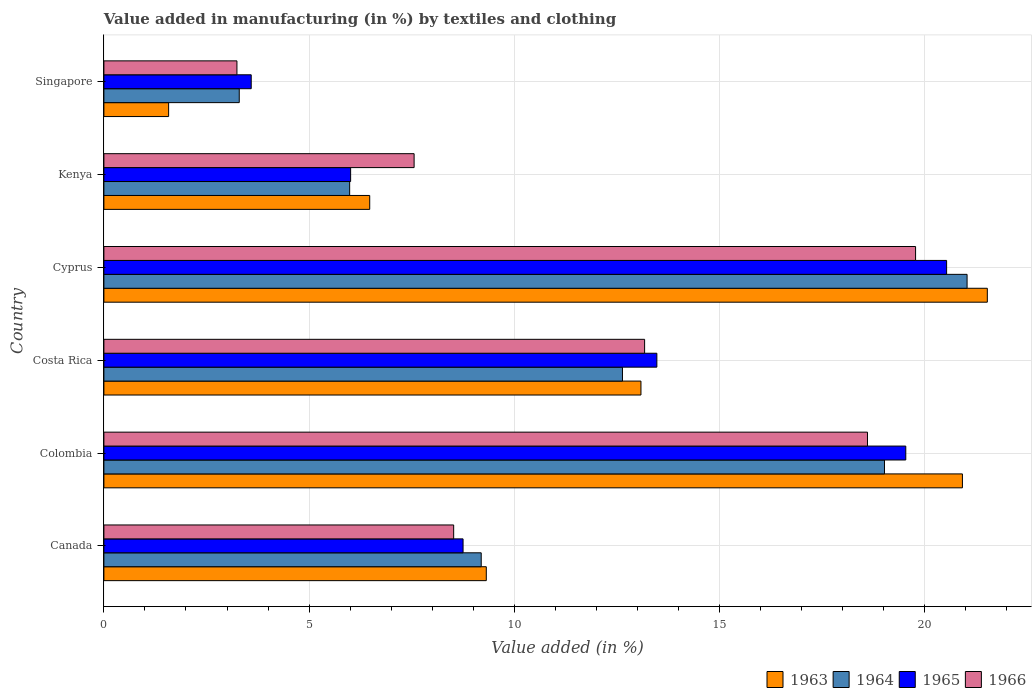How many groups of bars are there?
Provide a short and direct response. 6. How many bars are there on the 1st tick from the top?
Make the answer very short. 4. How many bars are there on the 3rd tick from the bottom?
Offer a terse response. 4. What is the label of the 4th group of bars from the top?
Make the answer very short. Costa Rica. In how many cases, is the number of bars for a given country not equal to the number of legend labels?
Give a very brief answer. 0. What is the percentage of value added in manufacturing by textiles and clothing in 1963 in Costa Rica?
Your answer should be compact. 13.08. Across all countries, what is the maximum percentage of value added in manufacturing by textiles and clothing in 1966?
Offer a very short reply. 19.78. Across all countries, what is the minimum percentage of value added in manufacturing by textiles and clothing in 1965?
Your answer should be very brief. 3.59. In which country was the percentage of value added in manufacturing by textiles and clothing in 1966 maximum?
Offer a very short reply. Cyprus. In which country was the percentage of value added in manufacturing by textiles and clothing in 1963 minimum?
Your answer should be very brief. Singapore. What is the total percentage of value added in manufacturing by textiles and clothing in 1966 in the graph?
Ensure brevity in your answer.  70.87. What is the difference between the percentage of value added in manufacturing by textiles and clothing in 1965 in Colombia and that in Singapore?
Give a very brief answer. 15.95. What is the difference between the percentage of value added in manufacturing by textiles and clothing in 1966 in Colombia and the percentage of value added in manufacturing by textiles and clothing in 1963 in Singapore?
Make the answer very short. 17.03. What is the average percentage of value added in manufacturing by textiles and clothing in 1965 per country?
Give a very brief answer. 11.98. What is the difference between the percentage of value added in manufacturing by textiles and clothing in 1965 and percentage of value added in manufacturing by textiles and clothing in 1963 in Singapore?
Offer a terse response. 2.01. In how many countries, is the percentage of value added in manufacturing by textiles and clothing in 1963 greater than 8 %?
Offer a very short reply. 4. What is the ratio of the percentage of value added in manufacturing by textiles and clothing in 1965 in Colombia to that in Cyprus?
Give a very brief answer. 0.95. Is the difference between the percentage of value added in manufacturing by textiles and clothing in 1965 in Costa Rica and Cyprus greater than the difference between the percentage of value added in manufacturing by textiles and clothing in 1963 in Costa Rica and Cyprus?
Provide a succinct answer. Yes. What is the difference between the highest and the second highest percentage of value added in manufacturing by textiles and clothing in 1966?
Offer a very short reply. 1.17. What is the difference between the highest and the lowest percentage of value added in manufacturing by textiles and clothing in 1965?
Offer a terse response. 16.94. Is the sum of the percentage of value added in manufacturing by textiles and clothing in 1965 in Cyprus and Singapore greater than the maximum percentage of value added in manufacturing by textiles and clothing in 1966 across all countries?
Make the answer very short. Yes. Is it the case that in every country, the sum of the percentage of value added in manufacturing by textiles and clothing in 1964 and percentage of value added in manufacturing by textiles and clothing in 1965 is greater than the sum of percentage of value added in manufacturing by textiles and clothing in 1966 and percentage of value added in manufacturing by textiles and clothing in 1963?
Your response must be concise. No. What does the 2nd bar from the bottom in Singapore represents?
Provide a succinct answer. 1964. How many countries are there in the graph?
Your response must be concise. 6. What is the difference between two consecutive major ticks on the X-axis?
Provide a succinct answer. 5. Does the graph contain any zero values?
Provide a short and direct response. No. Does the graph contain grids?
Provide a short and direct response. Yes. Where does the legend appear in the graph?
Provide a succinct answer. Bottom right. How many legend labels are there?
Offer a very short reply. 4. How are the legend labels stacked?
Your answer should be compact. Horizontal. What is the title of the graph?
Make the answer very short. Value added in manufacturing (in %) by textiles and clothing. Does "1983" appear as one of the legend labels in the graph?
Give a very brief answer. No. What is the label or title of the X-axis?
Give a very brief answer. Value added (in %). What is the Value added (in %) of 1963 in Canada?
Provide a succinct answer. 9.32. What is the Value added (in %) of 1964 in Canada?
Your response must be concise. 9.19. What is the Value added (in %) in 1965 in Canada?
Make the answer very short. 8.75. What is the Value added (in %) of 1966 in Canada?
Your answer should be compact. 8.52. What is the Value added (in %) of 1963 in Colombia?
Your answer should be very brief. 20.92. What is the Value added (in %) in 1964 in Colombia?
Provide a short and direct response. 19.02. What is the Value added (in %) of 1965 in Colombia?
Provide a short and direct response. 19.54. What is the Value added (in %) of 1966 in Colombia?
Provide a succinct answer. 18.6. What is the Value added (in %) in 1963 in Costa Rica?
Your response must be concise. 13.08. What is the Value added (in %) in 1964 in Costa Rica?
Your answer should be very brief. 12.63. What is the Value added (in %) of 1965 in Costa Rica?
Your response must be concise. 13.47. What is the Value added (in %) in 1966 in Costa Rica?
Your response must be concise. 13.17. What is the Value added (in %) of 1963 in Cyprus?
Ensure brevity in your answer.  21.52. What is the Value added (in %) in 1964 in Cyprus?
Provide a succinct answer. 21.03. What is the Value added (in %) of 1965 in Cyprus?
Provide a short and direct response. 20.53. What is the Value added (in %) of 1966 in Cyprus?
Your answer should be very brief. 19.78. What is the Value added (in %) in 1963 in Kenya?
Your answer should be compact. 6.48. What is the Value added (in %) in 1964 in Kenya?
Keep it short and to the point. 5.99. What is the Value added (in %) in 1965 in Kenya?
Offer a very short reply. 6.01. What is the Value added (in %) of 1966 in Kenya?
Your answer should be compact. 7.56. What is the Value added (in %) in 1963 in Singapore?
Keep it short and to the point. 1.58. What is the Value added (in %) in 1964 in Singapore?
Offer a terse response. 3.3. What is the Value added (in %) in 1965 in Singapore?
Your answer should be very brief. 3.59. What is the Value added (in %) in 1966 in Singapore?
Your answer should be very brief. 3.24. Across all countries, what is the maximum Value added (in %) in 1963?
Offer a very short reply. 21.52. Across all countries, what is the maximum Value added (in %) in 1964?
Keep it short and to the point. 21.03. Across all countries, what is the maximum Value added (in %) in 1965?
Ensure brevity in your answer.  20.53. Across all countries, what is the maximum Value added (in %) of 1966?
Your answer should be compact. 19.78. Across all countries, what is the minimum Value added (in %) in 1963?
Keep it short and to the point. 1.58. Across all countries, what is the minimum Value added (in %) in 1964?
Give a very brief answer. 3.3. Across all countries, what is the minimum Value added (in %) of 1965?
Your response must be concise. 3.59. Across all countries, what is the minimum Value added (in %) of 1966?
Keep it short and to the point. 3.24. What is the total Value added (in %) in 1963 in the graph?
Offer a very short reply. 72.9. What is the total Value added (in %) in 1964 in the graph?
Your response must be concise. 71.16. What is the total Value added (in %) of 1965 in the graph?
Your response must be concise. 71.89. What is the total Value added (in %) of 1966 in the graph?
Offer a terse response. 70.87. What is the difference between the Value added (in %) in 1963 in Canada and that in Colombia?
Offer a very short reply. -11.6. What is the difference between the Value added (in %) in 1964 in Canada and that in Colombia?
Make the answer very short. -9.82. What is the difference between the Value added (in %) in 1965 in Canada and that in Colombia?
Your answer should be very brief. -10.79. What is the difference between the Value added (in %) in 1966 in Canada and that in Colombia?
Make the answer very short. -10.08. What is the difference between the Value added (in %) in 1963 in Canada and that in Costa Rica?
Your response must be concise. -3.77. What is the difference between the Value added (in %) in 1964 in Canada and that in Costa Rica?
Offer a terse response. -3.44. What is the difference between the Value added (in %) in 1965 in Canada and that in Costa Rica?
Offer a very short reply. -4.72. What is the difference between the Value added (in %) in 1966 in Canada and that in Costa Rica?
Provide a short and direct response. -4.65. What is the difference between the Value added (in %) in 1963 in Canada and that in Cyprus?
Your answer should be compact. -12.21. What is the difference between the Value added (in %) of 1964 in Canada and that in Cyprus?
Provide a short and direct response. -11.84. What is the difference between the Value added (in %) of 1965 in Canada and that in Cyprus?
Your response must be concise. -11.78. What is the difference between the Value added (in %) in 1966 in Canada and that in Cyprus?
Give a very brief answer. -11.25. What is the difference between the Value added (in %) in 1963 in Canada and that in Kenya?
Your answer should be compact. 2.84. What is the difference between the Value added (in %) in 1964 in Canada and that in Kenya?
Give a very brief answer. 3.21. What is the difference between the Value added (in %) of 1965 in Canada and that in Kenya?
Ensure brevity in your answer.  2.74. What is the difference between the Value added (in %) of 1966 in Canada and that in Kenya?
Ensure brevity in your answer.  0.96. What is the difference between the Value added (in %) of 1963 in Canada and that in Singapore?
Offer a terse response. 7.74. What is the difference between the Value added (in %) of 1964 in Canada and that in Singapore?
Offer a terse response. 5.9. What is the difference between the Value added (in %) in 1965 in Canada and that in Singapore?
Offer a terse response. 5.16. What is the difference between the Value added (in %) of 1966 in Canada and that in Singapore?
Offer a very short reply. 5.28. What is the difference between the Value added (in %) in 1963 in Colombia and that in Costa Rica?
Your answer should be very brief. 7.83. What is the difference between the Value added (in %) in 1964 in Colombia and that in Costa Rica?
Keep it short and to the point. 6.38. What is the difference between the Value added (in %) of 1965 in Colombia and that in Costa Rica?
Your answer should be compact. 6.06. What is the difference between the Value added (in %) in 1966 in Colombia and that in Costa Rica?
Make the answer very short. 5.43. What is the difference between the Value added (in %) in 1963 in Colombia and that in Cyprus?
Offer a terse response. -0.61. What is the difference between the Value added (in %) in 1964 in Colombia and that in Cyprus?
Offer a very short reply. -2.01. What is the difference between the Value added (in %) in 1965 in Colombia and that in Cyprus?
Make the answer very short. -0.99. What is the difference between the Value added (in %) of 1966 in Colombia and that in Cyprus?
Provide a succinct answer. -1.17. What is the difference between the Value added (in %) in 1963 in Colombia and that in Kenya?
Offer a very short reply. 14.44. What is the difference between the Value added (in %) in 1964 in Colombia and that in Kenya?
Your answer should be compact. 13.03. What is the difference between the Value added (in %) of 1965 in Colombia and that in Kenya?
Your response must be concise. 13.53. What is the difference between the Value added (in %) in 1966 in Colombia and that in Kenya?
Your answer should be very brief. 11.05. What is the difference between the Value added (in %) in 1963 in Colombia and that in Singapore?
Provide a succinct answer. 19.34. What is the difference between the Value added (in %) of 1964 in Colombia and that in Singapore?
Make the answer very short. 15.72. What is the difference between the Value added (in %) of 1965 in Colombia and that in Singapore?
Make the answer very short. 15.95. What is the difference between the Value added (in %) in 1966 in Colombia and that in Singapore?
Offer a very short reply. 15.36. What is the difference between the Value added (in %) in 1963 in Costa Rica and that in Cyprus?
Provide a short and direct response. -8.44. What is the difference between the Value added (in %) in 1964 in Costa Rica and that in Cyprus?
Offer a terse response. -8.4. What is the difference between the Value added (in %) of 1965 in Costa Rica and that in Cyprus?
Offer a very short reply. -7.06. What is the difference between the Value added (in %) in 1966 in Costa Rica and that in Cyprus?
Give a very brief answer. -6.6. What is the difference between the Value added (in %) of 1963 in Costa Rica and that in Kenya?
Ensure brevity in your answer.  6.61. What is the difference between the Value added (in %) of 1964 in Costa Rica and that in Kenya?
Your answer should be very brief. 6.65. What is the difference between the Value added (in %) in 1965 in Costa Rica and that in Kenya?
Your response must be concise. 7.46. What is the difference between the Value added (in %) in 1966 in Costa Rica and that in Kenya?
Your answer should be compact. 5.62. What is the difference between the Value added (in %) of 1963 in Costa Rica and that in Singapore?
Your response must be concise. 11.51. What is the difference between the Value added (in %) in 1964 in Costa Rica and that in Singapore?
Make the answer very short. 9.34. What is the difference between the Value added (in %) of 1965 in Costa Rica and that in Singapore?
Your response must be concise. 9.88. What is the difference between the Value added (in %) of 1966 in Costa Rica and that in Singapore?
Provide a succinct answer. 9.93. What is the difference between the Value added (in %) of 1963 in Cyprus and that in Kenya?
Provide a succinct answer. 15.05. What is the difference between the Value added (in %) of 1964 in Cyprus and that in Kenya?
Provide a succinct answer. 15.04. What is the difference between the Value added (in %) in 1965 in Cyprus and that in Kenya?
Make the answer very short. 14.52. What is the difference between the Value added (in %) in 1966 in Cyprus and that in Kenya?
Offer a very short reply. 12.22. What is the difference between the Value added (in %) in 1963 in Cyprus and that in Singapore?
Give a very brief answer. 19.95. What is the difference between the Value added (in %) of 1964 in Cyprus and that in Singapore?
Ensure brevity in your answer.  17.73. What is the difference between the Value added (in %) in 1965 in Cyprus and that in Singapore?
Make the answer very short. 16.94. What is the difference between the Value added (in %) of 1966 in Cyprus and that in Singapore?
Make the answer very short. 16.53. What is the difference between the Value added (in %) of 1963 in Kenya and that in Singapore?
Provide a short and direct response. 4.9. What is the difference between the Value added (in %) of 1964 in Kenya and that in Singapore?
Your answer should be compact. 2.69. What is the difference between the Value added (in %) in 1965 in Kenya and that in Singapore?
Your answer should be very brief. 2.42. What is the difference between the Value added (in %) in 1966 in Kenya and that in Singapore?
Your answer should be compact. 4.32. What is the difference between the Value added (in %) in 1963 in Canada and the Value added (in %) in 1964 in Colombia?
Ensure brevity in your answer.  -9.7. What is the difference between the Value added (in %) of 1963 in Canada and the Value added (in %) of 1965 in Colombia?
Offer a terse response. -10.22. What is the difference between the Value added (in %) in 1963 in Canada and the Value added (in %) in 1966 in Colombia?
Your response must be concise. -9.29. What is the difference between the Value added (in %) in 1964 in Canada and the Value added (in %) in 1965 in Colombia?
Offer a terse response. -10.34. What is the difference between the Value added (in %) of 1964 in Canada and the Value added (in %) of 1966 in Colombia?
Provide a succinct answer. -9.41. What is the difference between the Value added (in %) of 1965 in Canada and the Value added (in %) of 1966 in Colombia?
Your response must be concise. -9.85. What is the difference between the Value added (in %) in 1963 in Canada and the Value added (in %) in 1964 in Costa Rica?
Provide a succinct answer. -3.32. What is the difference between the Value added (in %) in 1963 in Canada and the Value added (in %) in 1965 in Costa Rica?
Keep it short and to the point. -4.16. What is the difference between the Value added (in %) in 1963 in Canada and the Value added (in %) in 1966 in Costa Rica?
Provide a short and direct response. -3.86. What is the difference between the Value added (in %) in 1964 in Canada and the Value added (in %) in 1965 in Costa Rica?
Make the answer very short. -4.28. What is the difference between the Value added (in %) of 1964 in Canada and the Value added (in %) of 1966 in Costa Rica?
Your answer should be compact. -3.98. What is the difference between the Value added (in %) of 1965 in Canada and the Value added (in %) of 1966 in Costa Rica?
Offer a terse response. -4.42. What is the difference between the Value added (in %) in 1963 in Canada and the Value added (in %) in 1964 in Cyprus?
Provide a short and direct response. -11.71. What is the difference between the Value added (in %) of 1963 in Canada and the Value added (in %) of 1965 in Cyprus?
Your response must be concise. -11.21. What is the difference between the Value added (in %) in 1963 in Canada and the Value added (in %) in 1966 in Cyprus?
Give a very brief answer. -10.46. What is the difference between the Value added (in %) in 1964 in Canada and the Value added (in %) in 1965 in Cyprus?
Offer a very short reply. -11.34. What is the difference between the Value added (in %) in 1964 in Canada and the Value added (in %) in 1966 in Cyprus?
Your answer should be very brief. -10.58. What is the difference between the Value added (in %) in 1965 in Canada and the Value added (in %) in 1966 in Cyprus?
Your answer should be very brief. -11.02. What is the difference between the Value added (in %) of 1963 in Canada and the Value added (in %) of 1964 in Kenya?
Offer a terse response. 3.33. What is the difference between the Value added (in %) in 1963 in Canada and the Value added (in %) in 1965 in Kenya?
Your response must be concise. 3.31. What is the difference between the Value added (in %) of 1963 in Canada and the Value added (in %) of 1966 in Kenya?
Offer a very short reply. 1.76. What is the difference between the Value added (in %) of 1964 in Canada and the Value added (in %) of 1965 in Kenya?
Your response must be concise. 3.18. What is the difference between the Value added (in %) in 1964 in Canada and the Value added (in %) in 1966 in Kenya?
Your response must be concise. 1.64. What is the difference between the Value added (in %) of 1965 in Canada and the Value added (in %) of 1966 in Kenya?
Offer a terse response. 1.19. What is the difference between the Value added (in %) in 1963 in Canada and the Value added (in %) in 1964 in Singapore?
Keep it short and to the point. 6.02. What is the difference between the Value added (in %) in 1963 in Canada and the Value added (in %) in 1965 in Singapore?
Provide a succinct answer. 5.73. What is the difference between the Value added (in %) in 1963 in Canada and the Value added (in %) in 1966 in Singapore?
Offer a very short reply. 6.08. What is the difference between the Value added (in %) in 1964 in Canada and the Value added (in %) in 1965 in Singapore?
Offer a terse response. 5.6. What is the difference between the Value added (in %) of 1964 in Canada and the Value added (in %) of 1966 in Singapore?
Offer a very short reply. 5.95. What is the difference between the Value added (in %) in 1965 in Canada and the Value added (in %) in 1966 in Singapore?
Your response must be concise. 5.51. What is the difference between the Value added (in %) of 1963 in Colombia and the Value added (in %) of 1964 in Costa Rica?
Make the answer very short. 8.28. What is the difference between the Value added (in %) of 1963 in Colombia and the Value added (in %) of 1965 in Costa Rica?
Your answer should be compact. 7.44. What is the difference between the Value added (in %) of 1963 in Colombia and the Value added (in %) of 1966 in Costa Rica?
Your answer should be compact. 7.74. What is the difference between the Value added (in %) of 1964 in Colombia and the Value added (in %) of 1965 in Costa Rica?
Offer a terse response. 5.55. What is the difference between the Value added (in %) in 1964 in Colombia and the Value added (in %) in 1966 in Costa Rica?
Make the answer very short. 5.84. What is the difference between the Value added (in %) of 1965 in Colombia and the Value added (in %) of 1966 in Costa Rica?
Provide a short and direct response. 6.36. What is the difference between the Value added (in %) of 1963 in Colombia and the Value added (in %) of 1964 in Cyprus?
Your answer should be very brief. -0.11. What is the difference between the Value added (in %) in 1963 in Colombia and the Value added (in %) in 1965 in Cyprus?
Give a very brief answer. 0.39. What is the difference between the Value added (in %) in 1963 in Colombia and the Value added (in %) in 1966 in Cyprus?
Provide a short and direct response. 1.14. What is the difference between the Value added (in %) in 1964 in Colombia and the Value added (in %) in 1965 in Cyprus?
Provide a short and direct response. -1.51. What is the difference between the Value added (in %) in 1964 in Colombia and the Value added (in %) in 1966 in Cyprus?
Provide a short and direct response. -0.76. What is the difference between the Value added (in %) in 1965 in Colombia and the Value added (in %) in 1966 in Cyprus?
Your answer should be compact. -0.24. What is the difference between the Value added (in %) of 1963 in Colombia and the Value added (in %) of 1964 in Kenya?
Keep it short and to the point. 14.93. What is the difference between the Value added (in %) in 1963 in Colombia and the Value added (in %) in 1965 in Kenya?
Make the answer very short. 14.91. What is the difference between the Value added (in %) in 1963 in Colombia and the Value added (in %) in 1966 in Kenya?
Make the answer very short. 13.36. What is the difference between the Value added (in %) in 1964 in Colombia and the Value added (in %) in 1965 in Kenya?
Your response must be concise. 13.01. What is the difference between the Value added (in %) of 1964 in Colombia and the Value added (in %) of 1966 in Kenya?
Make the answer very short. 11.46. What is the difference between the Value added (in %) of 1965 in Colombia and the Value added (in %) of 1966 in Kenya?
Ensure brevity in your answer.  11.98. What is the difference between the Value added (in %) in 1963 in Colombia and the Value added (in %) in 1964 in Singapore?
Your response must be concise. 17.62. What is the difference between the Value added (in %) of 1963 in Colombia and the Value added (in %) of 1965 in Singapore?
Offer a terse response. 17.33. What is the difference between the Value added (in %) of 1963 in Colombia and the Value added (in %) of 1966 in Singapore?
Offer a terse response. 17.68. What is the difference between the Value added (in %) in 1964 in Colombia and the Value added (in %) in 1965 in Singapore?
Your response must be concise. 15.43. What is the difference between the Value added (in %) in 1964 in Colombia and the Value added (in %) in 1966 in Singapore?
Your answer should be compact. 15.78. What is the difference between the Value added (in %) in 1965 in Colombia and the Value added (in %) in 1966 in Singapore?
Ensure brevity in your answer.  16.3. What is the difference between the Value added (in %) in 1963 in Costa Rica and the Value added (in %) in 1964 in Cyprus?
Your answer should be compact. -7.95. What is the difference between the Value added (in %) of 1963 in Costa Rica and the Value added (in %) of 1965 in Cyprus?
Provide a succinct answer. -7.45. What is the difference between the Value added (in %) in 1963 in Costa Rica and the Value added (in %) in 1966 in Cyprus?
Offer a very short reply. -6.69. What is the difference between the Value added (in %) in 1964 in Costa Rica and the Value added (in %) in 1965 in Cyprus?
Offer a terse response. -7.9. What is the difference between the Value added (in %) of 1964 in Costa Rica and the Value added (in %) of 1966 in Cyprus?
Provide a short and direct response. -7.14. What is the difference between the Value added (in %) in 1965 in Costa Rica and the Value added (in %) in 1966 in Cyprus?
Give a very brief answer. -6.3. What is the difference between the Value added (in %) in 1963 in Costa Rica and the Value added (in %) in 1964 in Kenya?
Provide a succinct answer. 7.1. What is the difference between the Value added (in %) of 1963 in Costa Rica and the Value added (in %) of 1965 in Kenya?
Make the answer very short. 7.07. What is the difference between the Value added (in %) of 1963 in Costa Rica and the Value added (in %) of 1966 in Kenya?
Your response must be concise. 5.53. What is the difference between the Value added (in %) in 1964 in Costa Rica and the Value added (in %) in 1965 in Kenya?
Provide a succinct answer. 6.62. What is the difference between the Value added (in %) of 1964 in Costa Rica and the Value added (in %) of 1966 in Kenya?
Your answer should be very brief. 5.08. What is the difference between the Value added (in %) in 1965 in Costa Rica and the Value added (in %) in 1966 in Kenya?
Your response must be concise. 5.91. What is the difference between the Value added (in %) in 1963 in Costa Rica and the Value added (in %) in 1964 in Singapore?
Ensure brevity in your answer.  9.79. What is the difference between the Value added (in %) of 1963 in Costa Rica and the Value added (in %) of 1965 in Singapore?
Ensure brevity in your answer.  9.5. What is the difference between the Value added (in %) of 1963 in Costa Rica and the Value added (in %) of 1966 in Singapore?
Give a very brief answer. 9.84. What is the difference between the Value added (in %) of 1964 in Costa Rica and the Value added (in %) of 1965 in Singapore?
Offer a very short reply. 9.04. What is the difference between the Value added (in %) of 1964 in Costa Rica and the Value added (in %) of 1966 in Singapore?
Keep it short and to the point. 9.39. What is the difference between the Value added (in %) of 1965 in Costa Rica and the Value added (in %) of 1966 in Singapore?
Provide a succinct answer. 10.23. What is the difference between the Value added (in %) in 1963 in Cyprus and the Value added (in %) in 1964 in Kenya?
Provide a succinct answer. 15.54. What is the difference between the Value added (in %) of 1963 in Cyprus and the Value added (in %) of 1965 in Kenya?
Keep it short and to the point. 15.51. What is the difference between the Value added (in %) in 1963 in Cyprus and the Value added (in %) in 1966 in Kenya?
Offer a terse response. 13.97. What is the difference between the Value added (in %) of 1964 in Cyprus and the Value added (in %) of 1965 in Kenya?
Give a very brief answer. 15.02. What is the difference between the Value added (in %) in 1964 in Cyprus and the Value added (in %) in 1966 in Kenya?
Offer a terse response. 13.47. What is the difference between the Value added (in %) in 1965 in Cyprus and the Value added (in %) in 1966 in Kenya?
Offer a very short reply. 12.97. What is the difference between the Value added (in %) of 1963 in Cyprus and the Value added (in %) of 1964 in Singapore?
Your answer should be compact. 18.23. What is the difference between the Value added (in %) in 1963 in Cyprus and the Value added (in %) in 1965 in Singapore?
Your answer should be very brief. 17.93. What is the difference between the Value added (in %) of 1963 in Cyprus and the Value added (in %) of 1966 in Singapore?
Your response must be concise. 18.28. What is the difference between the Value added (in %) in 1964 in Cyprus and the Value added (in %) in 1965 in Singapore?
Offer a terse response. 17.44. What is the difference between the Value added (in %) in 1964 in Cyprus and the Value added (in %) in 1966 in Singapore?
Provide a short and direct response. 17.79. What is the difference between the Value added (in %) in 1965 in Cyprus and the Value added (in %) in 1966 in Singapore?
Your response must be concise. 17.29. What is the difference between the Value added (in %) of 1963 in Kenya and the Value added (in %) of 1964 in Singapore?
Keep it short and to the point. 3.18. What is the difference between the Value added (in %) of 1963 in Kenya and the Value added (in %) of 1965 in Singapore?
Provide a succinct answer. 2.89. What is the difference between the Value added (in %) of 1963 in Kenya and the Value added (in %) of 1966 in Singapore?
Give a very brief answer. 3.24. What is the difference between the Value added (in %) of 1964 in Kenya and the Value added (in %) of 1965 in Singapore?
Offer a very short reply. 2.4. What is the difference between the Value added (in %) in 1964 in Kenya and the Value added (in %) in 1966 in Singapore?
Offer a terse response. 2.75. What is the difference between the Value added (in %) of 1965 in Kenya and the Value added (in %) of 1966 in Singapore?
Give a very brief answer. 2.77. What is the average Value added (in %) in 1963 per country?
Offer a terse response. 12.15. What is the average Value added (in %) in 1964 per country?
Provide a succinct answer. 11.86. What is the average Value added (in %) of 1965 per country?
Make the answer very short. 11.98. What is the average Value added (in %) of 1966 per country?
Your answer should be compact. 11.81. What is the difference between the Value added (in %) of 1963 and Value added (in %) of 1964 in Canada?
Provide a short and direct response. 0.12. What is the difference between the Value added (in %) in 1963 and Value added (in %) in 1965 in Canada?
Offer a terse response. 0.57. What is the difference between the Value added (in %) in 1963 and Value added (in %) in 1966 in Canada?
Give a very brief answer. 0.8. What is the difference between the Value added (in %) of 1964 and Value added (in %) of 1965 in Canada?
Offer a very short reply. 0.44. What is the difference between the Value added (in %) of 1964 and Value added (in %) of 1966 in Canada?
Offer a terse response. 0.67. What is the difference between the Value added (in %) in 1965 and Value added (in %) in 1966 in Canada?
Make the answer very short. 0.23. What is the difference between the Value added (in %) of 1963 and Value added (in %) of 1964 in Colombia?
Your answer should be very brief. 1.9. What is the difference between the Value added (in %) of 1963 and Value added (in %) of 1965 in Colombia?
Ensure brevity in your answer.  1.38. What is the difference between the Value added (in %) in 1963 and Value added (in %) in 1966 in Colombia?
Provide a short and direct response. 2.31. What is the difference between the Value added (in %) in 1964 and Value added (in %) in 1965 in Colombia?
Your response must be concise. -0.52. What is the difference between the Value added (in %) of 1964 and Value added (in %) of 1966 in Colombia?
Ensure brevity in your answer.  0.41. What is the difference between the Value added (in %) of 1965 and Value added (in %) of 1966 in Colombia?
Keep it short and to the point. 0.93. What is the difference between the Value added (in %) of 1963 and Value added (in %) of 1964 in Costa Rica?
Keep it short and to the point. 0.45. What is the difference between the Value added (in %) in 1963 and Value added (in %) in 1965 in Costa Rica?
Ensure brevity in your answer.  -0.39. What is the difference between the Value added (in %) in 1963 and Value added (in %) in 1966 in Costa Rica?
Your answer should be compact. -0.09. What is the difference between the Value added (in %) of 1964 and Value added (in %) of 1965 in Costa Rica?
Provide a short and direct response. -0.84. What is the difference between the Value added (in %) in 1964 and Value added (in %) in 1966 in Costa Rica?
Keep it short and to the point. -0.54. What is the difference between the Value added (in %) in 1965 and Value added (in %) in 1966 in Costa Rica?
Provide a short and direct response. 0.3. What is the difference between the Value added (in %) in 1963 and Value added (in %) in 1964 in Cyprus?
Offer a terse response. 0.49. What is the difference between the Value added (in %) in 1963 and Value added (in %) in 1966 in Cyprus?
Give a very brief answer. 1.75. What is the difference between the Value added (in %) in 1964 and Value added (in %) in 1965 in Cyprus?
Ensure brevity in your answer.  0.5. What is the difference between the Value added (in %) of 1964 and Value added (in %) of 1966 in Cyprus?
Offer a terse response. 1.25. What is the difference between the Value added (in %) of 1965 and Value added (in %) of 1966 in Cyprus?
Provide a short and direct response. 0.76. What is the difference between the Value added (in %) of 1963 and Value added (in %) of 1964 in Kenya?
Ensure brevity in your answer.  0.49. What is the difference between the Value added (in %) of 1963 and Value added (in %) of 1965 in Kenya?
Make the answer very short. 0.47. What is the difference between the Value added (in %) in 1963 and Value added (in %) in 1966 in Kenya?
Offer a terse response. -1.08. What is the difference between the Value added (in %) of 1964 and Value added (in %) of 1965 in Kenya?
Your response must be concise. -0.02. What is the difference between the Value added (in %) of 1964 and Value added (in %) of 1966 in Kenya?
Your answer should be very brief. -1.57. What is the difference between the Value added (in %) of 1965 and Value added (in %) of 1966 in Kenya?
Give a very brief answer. -1.55. What is the difference between the Value added (in %) of 1963 and Value added (in %) of 1964 in Singapore?
Make the answer very short. -1.72. What is the difference between the Value added (in %) of 1963 and Value added (in %) of 1965 in Singapore?
Give a very brief answer. -2.01. What is the difference between the Value added (in %) of 1963 and Value added (in %) of 1966 in Singapore?
Your answer should be very brief. -1.66. What is the difference between the Value added (in %) of 1964 and Value added (in %) of 1965 in Singapore?
Offer a terse response. -0.29. What is the difference between the Value added (in %) in 1964 and Value added (in %) in 1966 in Singapore?
Offer a terse response. 0.06. What is the difference between the Value added (in %) of 1965 and Value added (in %) of 1966 in Singapore?
Make the answer very short. 0.35. What is the ratio of the Value added (in %) in 1963 in Canada to that in Colombia?
Your answer should be compact. 0.45. What is the ratio of the Value added (in %) in 1964 in Canada to that in Colombia?
Your answer should be very brief. 0.48. What is the ratio of the Value added (in %) of 1965 in Canada to that in Colombia?
Your answer should be very brief. 0.45. What is the ratio of the Value added (in %) of 1966 in Canada to that in Colombia?
Your answer should be compact. 0.46. What is the ratio of the Value added (in %) of 1963 in Canada to that in Costa Rica?
Provide a succinct answer. 0.71. What is the ratio of the Value added (in %) of 1964 in Canada to that in Costa Rica?
Keep it short and to the point. 0.73. What is the ratio of the Value added (in %) in 1965 in Canada to that in Costa Rica?
Offer a very short reply. 0.65. What is the ratio of the Value added (in %) in 1966 in Canada to that in Costa Rica?
Offer a very short reply. 0.65. What is the ratio of the Value added (in %) in 1963 in Canada to that in Cyprus?
Your response must be concise. 0.43. What is the ratio of the Value added (in %) in 1964 in Canada to that in Cyprus?
Provide a short and direct response. 0.44. What is the ratio of the Value added (in %) in 1965 in Canada to that in Cyprus?
Offer a terse response. 0.43. What is the ratio of the Value added (in %) of 1966 in Canada to that in Cyprus?
Your response must be concise. 0.43. What is the ratio of the Value added (in %) in 1963 in Canada to that in Kenya?
Your response must be concise. 1.44. What is the ratio of the Value added (in %) of 1964 in Canada to that in Kenya?
Offer a terse response. 1.54. What is the ratio of the Value added (in %) of 1965 in Canada to that in Kenya?
Your response must be concise. 1.46. What is the ratio of the Value added (in %) of 1966 in Canada to that in Kenya?
Make the answer very short. 1.13. What is the ratio of the Value added (in %) in 1963 in Canada to that in Singapore?
Make the answer very short. 5.91. What is the ratio of the Value added (in %) of 1964 in Canada to that in Singapore?
Keep it short and to the point. 2.79. What is the ratio of the Value added (in %) in 1965 in Canada to that in Singapore?
Your answer should be very brief. 2.44. What is the ratio of the Value added (in %) in 1966 in Canada to that in Singapore?
Your answer should be very brief. 2.63. What is the ratio of the Value added (in %) in 1963 in Colombia to that in Costa Rica?
Make the answer very short. 1.6. What is the ratio of the Value added (in %) of 1964 in Colombia to that in Costa Rica?
Give a very brief answer. 1.51. What is the ratio of the Value added (in %) in 1965 in Colombia to that in Costa Rica?
Ensure brevity in your answer.  1.45. What is the ratio of the Value added (in %) in 1966 in Colombia to that in Costa Rica?
Your answer should be very brief. 1.41. What is the ratio of the Value added (in %) in 1963 in Colombia to that in Cyprus?
Keep it short and to the point. 0.97. What is the ratio of the Value added (in %) of 1964 in Colombia to that in Cyprus?
Your answer should be compact. 0.9. What is the ratio of the Value added (in %) in 1965 in Colombia to that in Cyprus?
Offer a very short reply. 0.95. What is the ratio of the Value added (in %) in 1966 in Colombia to that in Cyprus?
Keep it short and to the point. 0.94. What is the ratio of the Value added (in %) in 1963 in Colombia to that in Kenya?
Your answer should be very brief. 3.23. What is the ratio of the Value added (in %) in 1964 in Colombia to that in Kenya?
Give a very brief answer. 3.18. What is the ratio of the Value added (in %) in 1965 in Colombia to that in Kenya?
Your answer should be very brief. 3.25. What is the ratio of the Value added (in %) in 1966 in Colombia to that in Kenya?
Keep it short and to the point. 2.46. What is the ratio of the Value added (in %) of 1963 in Colombia to that in Singapore?
Your answer should be compact. 13.26. What is the ratio of the Value added (in %) in 1964 in Colombia to that in Singapore?
Offer a very short reply. 5.77. What is the ratio of the Value added (in %) of 1965 in Colombia to that in Singapore?
Ensure brevity in your answer.  5.44. What is the ratio of the Value added (in %) in 1966 in Colombia to that in Singapore?
Ensure brevity in your answer.  5.74. What is the ratio of the Value added (in %) in 1963 in Costa Rica to that in Cyprus?
Your answer should be very brief. 0.61. What is the ratio of the Value added (in %) of 1964 in Costa Rica to that in Cyprus?
Keep it short and to the point. 0.6. What is the ratio of the Value added (in %) in 1965 in Costa Rica to that in Cyprus?
Ensure brevity in your answer.  0.66. What is the ratio of the Value added (in %) of 1966 in Costa Rica to that in Cyprus?
Offer a very short reply. 0.67. What is the ratio of the Value added (in %) in 1963 in Costa Rica to that in Kenya?
Your response must be concise. 2.02. What is the ratio of the Value added (in %) in 1964 in Costa Rica to that in Kenya?
Offer a very short reply. 2.11. What is the ratio of the Value added (in %) of 1965 in Costa Rica to that in Kenya?
Give a very brief answer. 2.24. What is the ratio of the Value added (in %) of 1966 in Costa Rica to that in Kenya?
Your response must be concise. 1.74. What is the ratio of the Value added (in %) of 1963 in Costa Rica to that in Singapore?
Ensure brevity in your answer.  8.3. What is the ratio of the Value added (in %) in 1964 in Costa Rica to that in Singapore?
Offer a terse response. 3.83. What is the ratio of the Value added (in %) in 1965 in Costa Rica to that in Singapore?
Your answer should be compact. 3.75. What is the ratio of the Value added (in %) of 1966 in Costa Rica to that in Singapore?
Keep it short and to the point. 4.06. What is the ratio of the Value added (in %) of 1963 in Cyprus to that in Kenya?
Ensure brevity in your answer.  3.32. What is the ratio of the Value added (in %) in 1964 in Cyprus to that in Kenya?
Offer a very short reply. 3.51. What is the ratio of the Value added (in %) in 1965 in Cyprus to that in Kenya?
Ensure brevity in your answer.  3.42. What is the ratio of the Value added (in %) in 1966 in Cyprus to that in Kenya?
Make the answer very short. 2.62. What is the ratio of the Value added (in %) of 1963 in Cyprus to that in Singapore?
Offer a terse response. 13.65. What is the ratio of the Value added (in %) in 1964 in Cyprus to that in Singapore?
Your response must be concise. 6.38. What is the ratio of the Value added (in %) of 1965 in Cyprus to that in Singapore?
Provide a succinct answer. 5.72. What is the ratio of the Value added (in %) in 1966 in Cyprus to that in Singapore?
Make the answer very short. 6.1. What is the ratio of the Value added (in %) of 1963 in Kenya to that in Singapore?
Ensure brevity in your answer.  4.11. What is the ratio of the Value added (in %) in 1964 in Kenya to that in Singapore?
Provide a short and direct response. 1.82. What is the ratio of the Value added (in %) in 1965 in Kenya to that in Singapore?
Provide a succinct answer. 1.67. What is the ratio of the Value added (in %) of 1966 in Kenya to that in Singapore?
Ensure brevity in your answer.  2.33. What is the difference between the highest and the second highest Value added (in %) in 1963?
Provide a short and direct response. 0.61. What is the difference between the highest and the second highest Value added (in %) of 1964?
Make the answer very short. 2.01. What is the difference between the highest and the second highest Value added (in %) of 1966?
Your answer should be compact. 1.17. What is the difference between the highest and the lowest Value added (in %) in 1963?
Offer a very short reply. 19.95. What is the difference between the highest and the lowest Value added (in %) of 1964?
Make the answer very short. 17.73. What is the difference between the highest and the lowest Value added (in %) in 1965?
Provide a short and direct response. 16.94. What is the difference between the highest and the lowest Value added (in %) in 1966?
Provide a short and direct response. 16.53. 